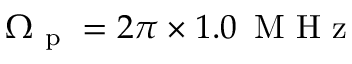<formula> <loc_0><loc_0><loc_500><loc_500>\Omega _ { p } = 2 \pi \times 1 . 0 \, M H z</formula> 